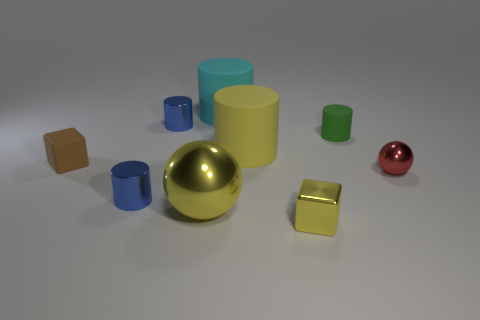There is a cyan cylinder that is made of the same material as the brown thing; what is its size?
Your answer should be very brief. Large. The tiny matte thing that is on the left side of the large object in front of the block that is behind the large yellow ball is what shape?
Keep it short and to the point. Cube. The yellow object that is the same shape as the tiny red thing is what size?
Give a very brief answer. Large. There is a matte thing that is both to the left of the small green matte object and behind the yellow matte thing; what size is it?
Make the answer very short. Large. The large rubber thing that is the same color as the big ball is what shape?
Your answer should be very brief. Cylinder. The metal block has what color?
Offer a terse response. Yellow. There is a object that is in front of the big yellow sphere; what is its size?
Ensure brevity in your answer.  Small. There is a small yellow metallic cube that is in front of the blue shiny thing behind the large yellow matte object; how many brown matte blocks are on the right side of it?
Make the answer very short. 0. What color is the ball behind the large object in front of the red thing?
Provide a succinct answer. Red. Are there any cyan cylinders that have the same size as the red metal thing?
Ensure brevity in your answer.  No. 